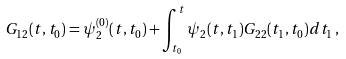<formula> <loc_0><loc_0><loc_500><loc_500>G _ { 1 2 } ( t , t _ { 0 } ) = \psi ^ { ( 0 ) } _ { 2 } ( t , t _ { 0 } ) + \int _ { t _ { 0 } } ^ { t } \psi _ { 2 } ( t , t _ { 1 } ) G _ { 2 2 } ( t _ { 1 } , t _ { 0 } ) d t _ { 1 } \, ,</formula> 